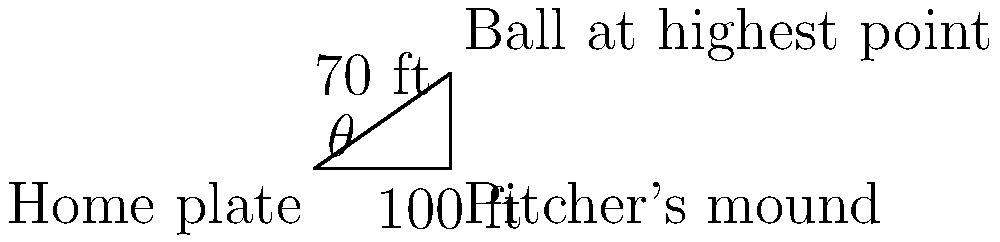As a retired baseball player, you're analyzing the trajectory of a pitch. The ball reaches its highest point 70 feet above the ground and 100 feet away from home plate horizontally. What is the angle $\theta$ (in degrees) at which the ball left the pitcher's hand, assuming it was released at ground level? To solve this problem, we'll use trigonometry:

1) We have a right triangle with the following measurements:
   - Adjacent side (horizontal distance) = 100 ft
   - Opposite side (vertical height) = 70 ft
   - Hypotenuse (path of the ball)

2) To find the angle $\theta$, we'll use the tangent function:

   $\tan(\theta) = \frac{\text{opposite}}{\text{adjacent}} = \frac{70}{100}$

3) To get $\theta$, we need to use the inverse tangent (arctan or $\tan^{-1}$):

   $\theta = \tan^{-1}(\frac{70}{100})$

4) Using a calculator or trigonometric tables:

   $\theta \approx 34.99°$

5) Rounding to the nearest degree:

   $\theta \approx 35°$

This angle represents the initial trajectory of the ball as it left the pitcher's hand, assuming it was released at ground level.
Answer: $35°$ 